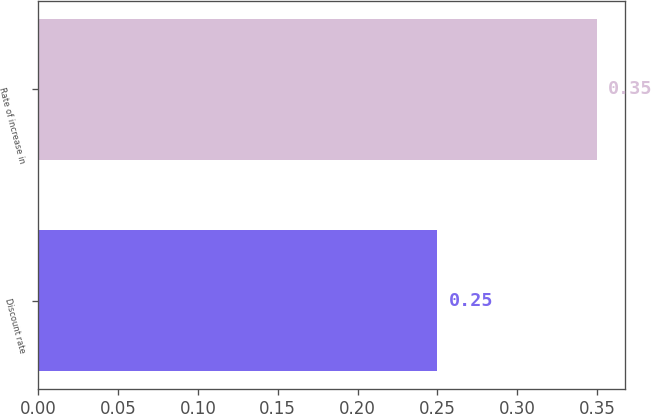Convert chart to OTSL. <chart><loc_0><loc_0><loc_500><loc_500><bar_chart><fcel>Discount rate<fcel>Rate of increase in<nl><fcel>0.25<fcel>0.35<nl></chart> 